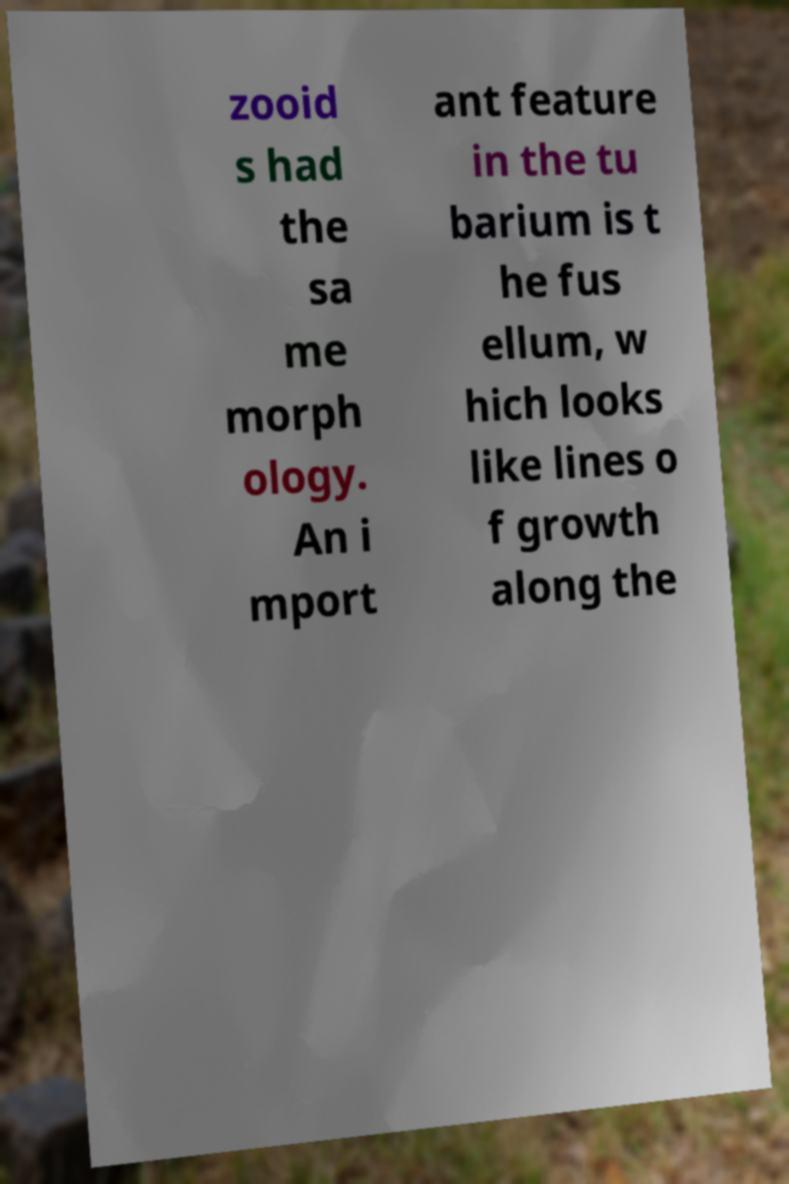Could you assist in decoding the text presented in this image and type it out clearly? zooid s had the sa me morph ology. An i mport ant feature in the tu barium is t he fus ellum, w hich looks like lines o f growth along the 